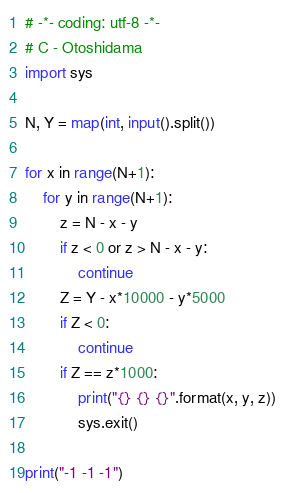<code> <loc_0><loc_0><loc_500><loc_500><_Python_># -*- coding: utf-8 -*-
# C - Otoshidama
import sys

N, Y = map(int, input().split())

for x in range(N+1):
    for y in range(N+1):
        z = N - x - y
        if z < 0 or z > N - x - y:
            continue
        Z = Y - x*10000 - y*5000
        if Z < 0:
            continue
        if Z == z*1000:
            print("{} {} {}".format(x, y, z))
            sys.exit()

print("-1 -1 -1")
</code> 